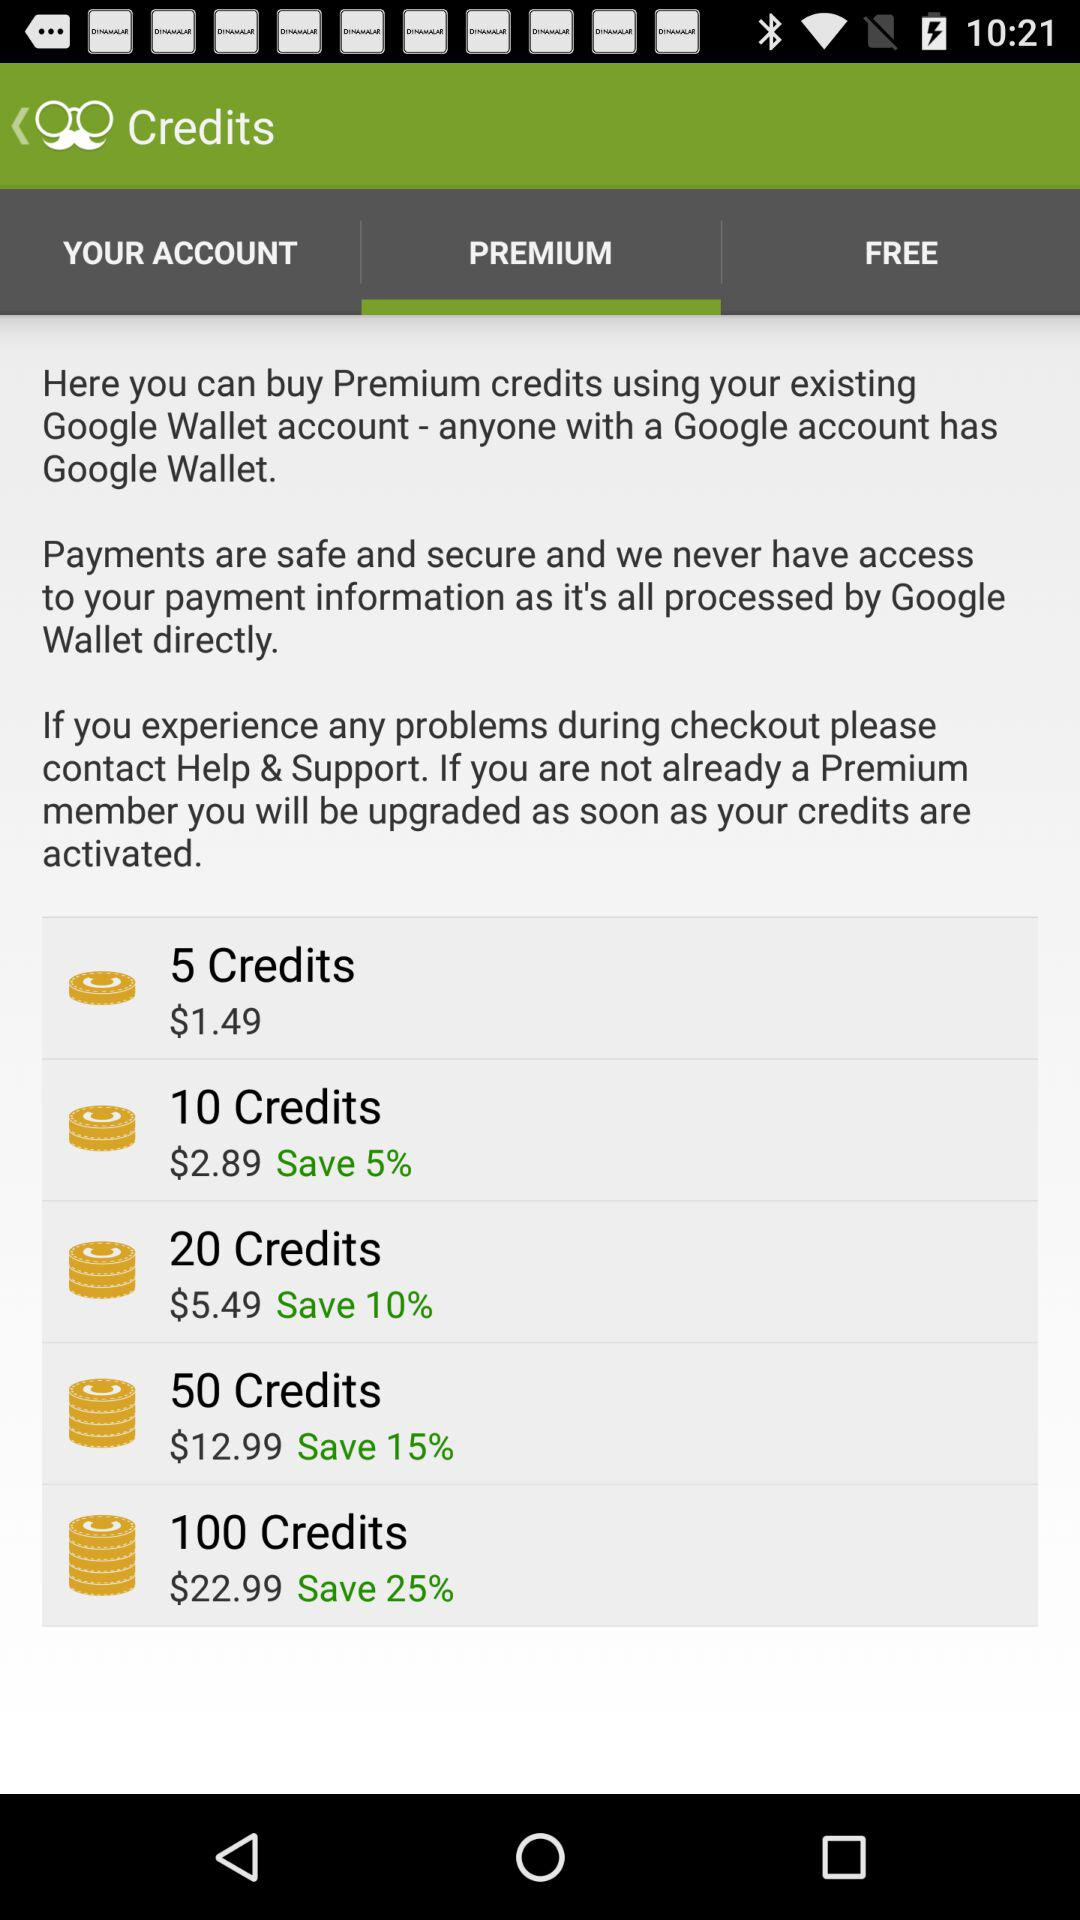What are the different options for premium credits? The different options for premium credits are "5 Credits", "10 Credits", "20 Credits", "50 Credits", and "100 Credits". 